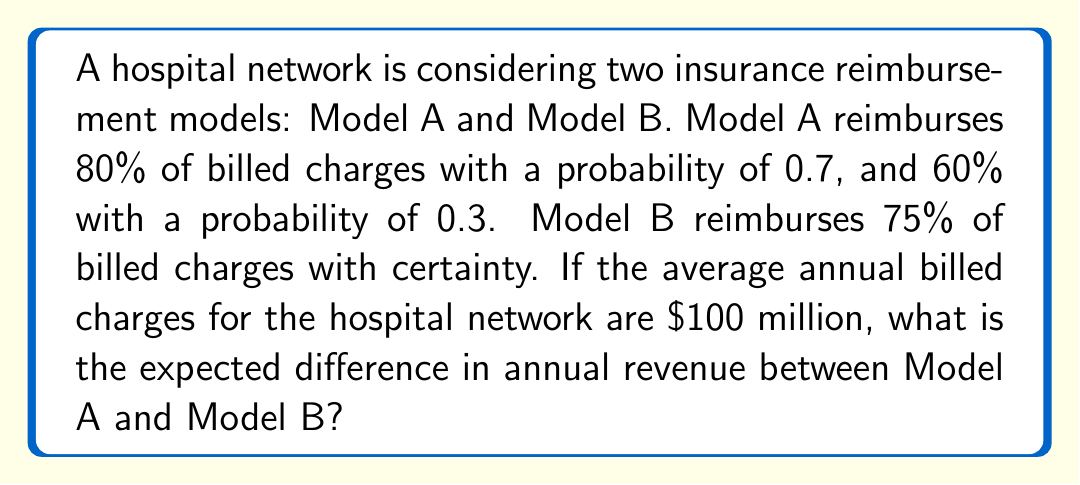Can you solve this math problem? Let's approach this step-by-step:

1) First, let's calculate the expected reimbursement rate for Model A:

   $E(A) = 0.8 \times 0.7 + 0.6 \times 0.3$
   $E(A) = 0.56 + 0.18 = 0.74$ or 74%

2) Model B has a certain reimbursement rate of 75% or 0.75

3) Now, let's calculate the expected annual revenue for each model:

   Model A: $E(R_A) = \$100,000,000 \times 0.74 = \$74,000,000$
   Model B: $E(R_B) = \$100,000,000 \times 0.75 = \$75,000,000$

4) To find the difference, we subtract:

   $\text{Difference} = E(R_B) - E(R_A)$
   $\text{Difference} = \$75,000,000 - \$74,000,000 = \$1,000,000$

Therefore, the expected difference in annual revenue between Model B and Model A is $1 million in favor of Model B.
Answer: $1,000,000 